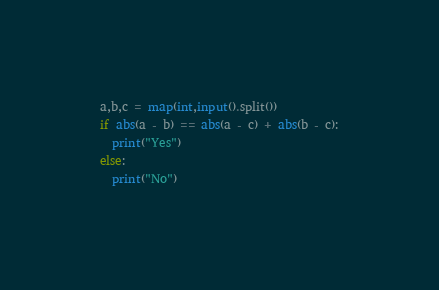Convert code to text. <code><loc_0><loc_0><loc_500><loc_500><_Python_>a,b,c = map(int,input().split())
if abs(a - b) == abs(a - c) + abs(b - c):
  print("Yes")
else:
  print("No")
</code> 